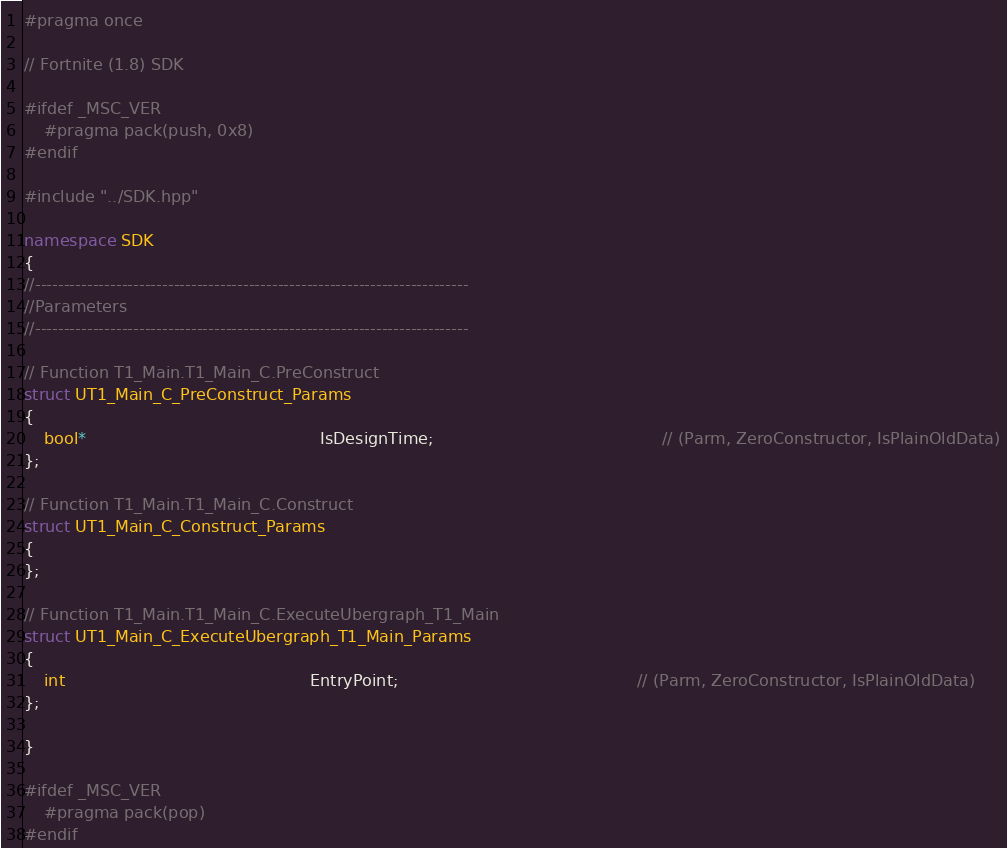<code> <loc_0><loc_0><loc_500><loc_500><_C++_>#pragma once

// Fortnite (1.8) SDK

#ifdef _MSC_VER
	#pragma pack(push, 0x8)
#endif

#include "../SDK.hpp"

namespace SDK
{
//---------------------------------------------------------------------------
//Parameters
//---------------------------------------------------------------------------

// Function T1_Main.T1_Main_C.PreConstruct
struct UT1_Main_C_PreConstruct_Params
{
	bool*                                              IsDesignTime;                                             // (Parm, ZeroConstructor, IsPlainOldData)
};

// Function T1_Main.T1_Main_C.Construct
struct UT1_Main_C_Construct_Params
{
};

// Function T1_Main.T1_Main_C.ExecuteUbergraph_T1_Main
struct UT1_Main_C_ExecuteUbergraph_T1_Main_Params
{
	int                                                EntryPoint;                                               // (Parm, ZeroConstructor, IsPlainOldData)
};

}

#ifdef _MSC_VER
	#pragma pack(pop)
#endif
</code> 